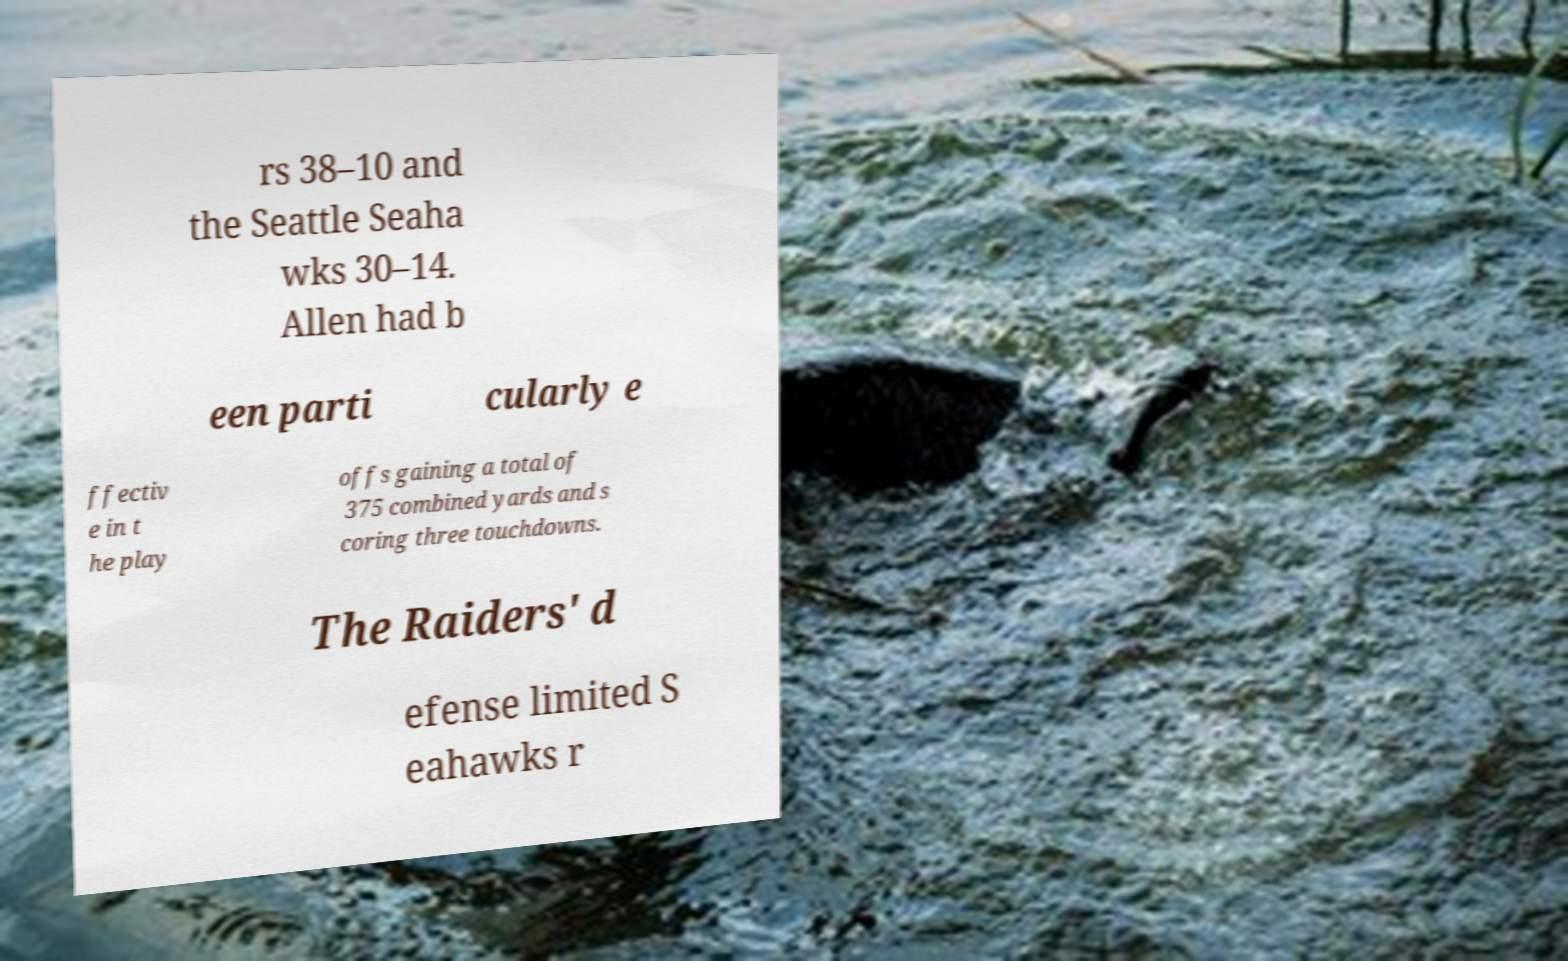Can you accurately transcribe the text from the provided image for me? rs 38–10 and the Seattle Seaha wks 30–14. Allen had b een parti cularly e ffectiv e in t he play offs gaining a total of 375 combined yards and s coring three touchdowns. The Raiders' d efense limited S eahawks r 